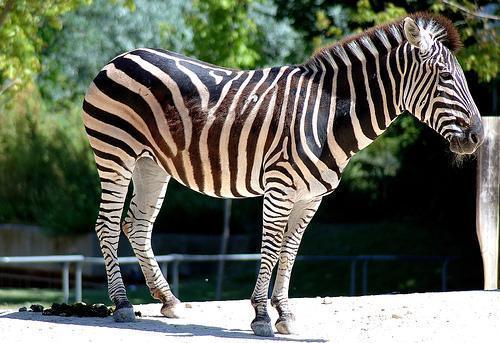How many zebras are there?
Give a very brief answer. 1. How many legs does the zebra have?
Give a very brief answer. 4. 